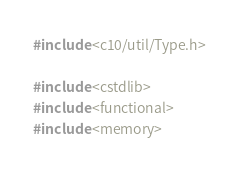Convert code to text. <code><loc_0><loc_0><loc_500><loc_500><_C++_>#include <c10/util/Type.h>

#include <cstdlib>
#include <functional>
#include <memory>
</code> 